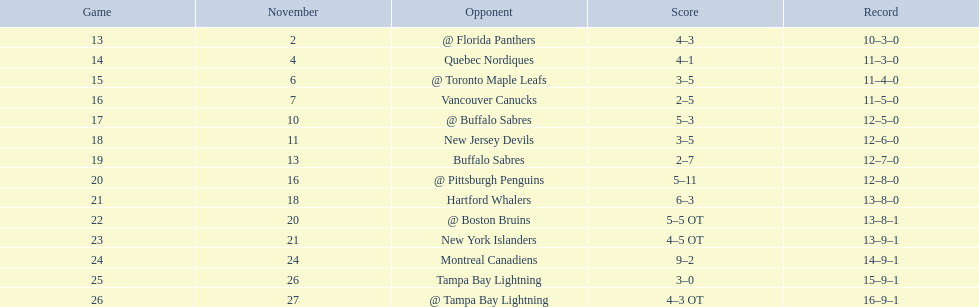Who are all of the teams? @ Florida Panthers, Quebec Nordiques, @ Toronto Maple Leafs, Vancouver Canucks, @ Buffalo Sabres, New Jersey Devils, Buffalo Sabres, @ Pittsburgh Penguins, Hartford Whalers, @ Boston Bruins, New York Islanders, Montreal Canadiens, Tampa Bay Lightning. What games finished in overtime? 22, 23, 26. In game number 23, who did they face? New York Islanders. 